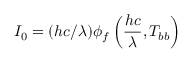<formula> <loc_0><loc_0><loc_500><loc_500>I _ { 0 } = ( h c / \lambda ) \phi _ { f } \left ( \frac { h c } { \lambda } , T _ { b b } \right )</formula> 